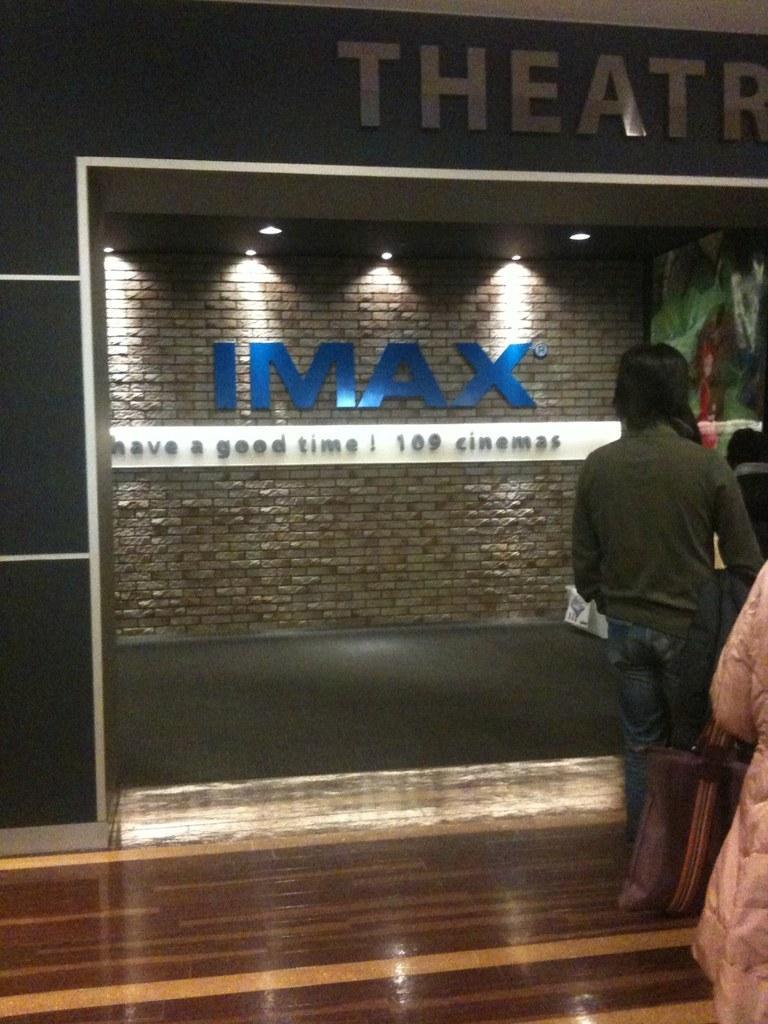In one or two sentences, can you explain what this image depicts? On the right side, we see a woman is wearing the handbag. In front of her, we see a man is standing. At the bottom, we see the wooden floor. In the background, we see the wall which is made up of bricks and we see some text written on the wall. At the top, we see a board in black color with some text written on it. 